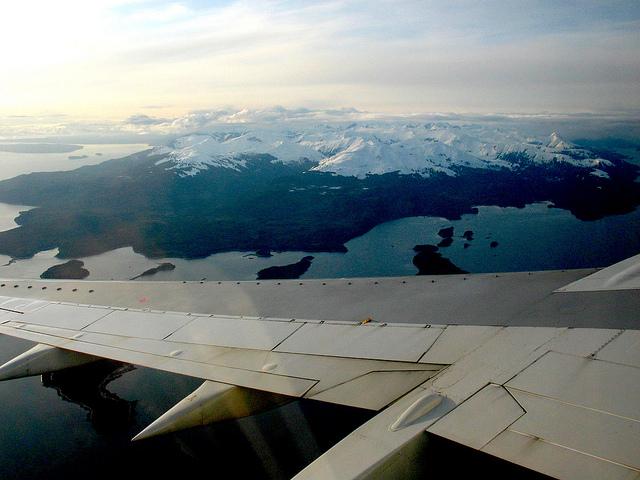Is the plane over water?
Concise answer only. Yes. Is the plane in flight?
Concise answer only. Yes. Is that a sea?
Quick response, please. Yes. What is on top of the mountains?
Concise answer only. Snow. 